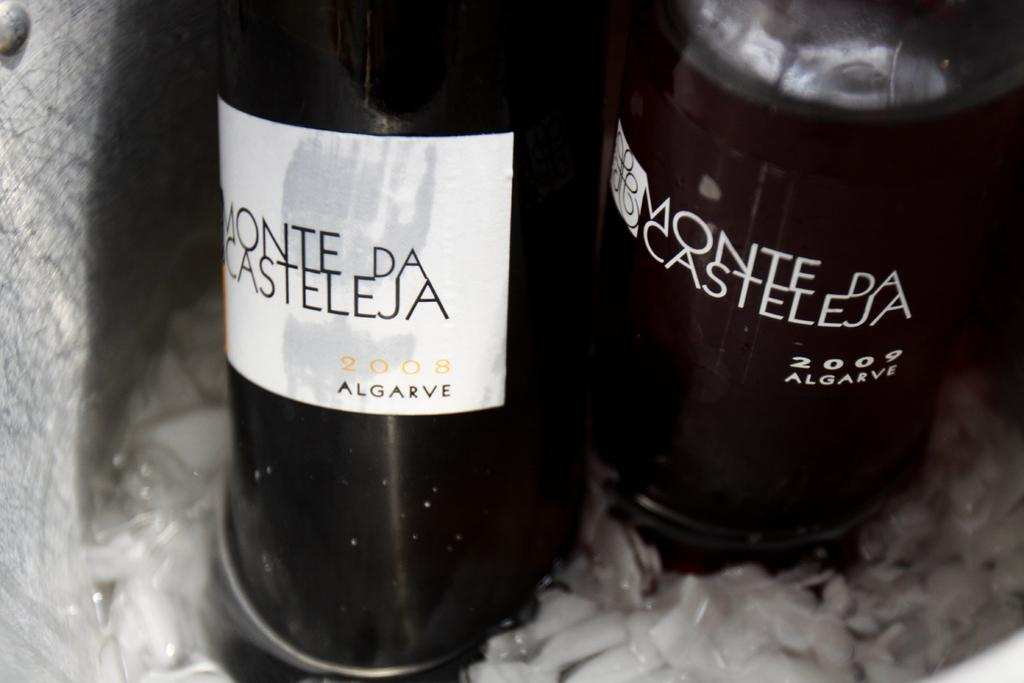Provide a one-sentence caption for the provided image. A bottle of wine called Monte de Casteleja. 